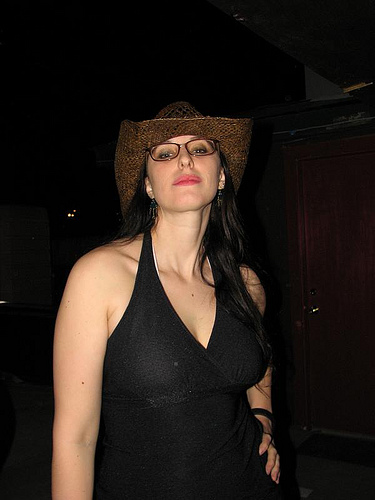<image>
Is the head in front of the neck? No. The head is not in front of the neck. The spatial positioning shows a different relationship between these objects. 